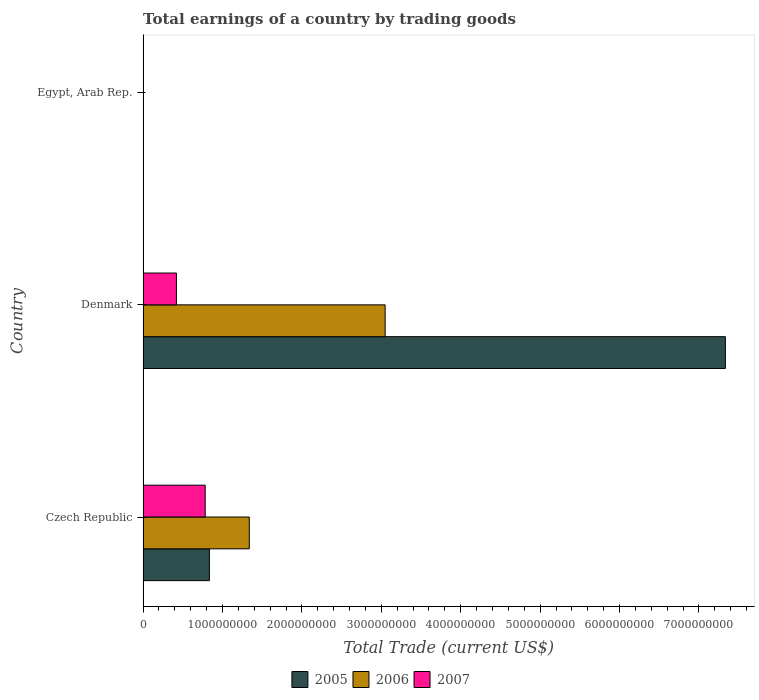How many different coloured bars are there?
Ensure brevity in your answer.  3. Are the number of bars on each tick of the Y-axis equal?
Give a very brief answer. No. How many bars are there on the 3rd tick from the top?
Offer a terse response. 3. How many bars are there on the 3rd tick from the bottom?
Offer a very short reply. 0. In how many cases, is the number of bars for a given country not equal to the number of legend labels?
Offer a terse response. 1. What is the total earnings in 2007 in Czech Republic?
Offer a terse response. 7.83e+08. Across all countries, what is the maximum total earnings in 2005?
Make the answer very short. 7.33e+09. Across all countries, what is the minimum total earnings in 2006?
Provide a short and direct response. 0. In which country was the total earnings in 2006 maximum?
Give a very brief answer. Denmark. What is the total total earnings in 2005 in the graph?
Give a very brief answer. 8.17e+09. What is the difference between the total earnings in 2007 in Czech Republic and that in Denmark?
Keep it short and to the point. 3.62e+08. What is the difference between the total earnings in 2007 in Denmark and the total earnings in 2005 in Czech Republic?
Your answer should be compact. -4.15e+08. What is the average total earnings in 2006 per country?
Keep it short and to the point. 1.46e+09. What is the difference between the total earnings in 2005 and total earnings in 2006 in Czech Republic?
Give a very brief answer. -5.02e+08. In how many countries, is the total earnings in 2006 greater than 3800000000 US$?
Ensure brevity in your answer.  0. What is the ratio of the total earnings in 2005 in Czech Republic to that in Denmark?
Your answer should be very brief. 0.11. Is the total earnings in 2006 in Czech Republic less than that in Denmark?
Provide a short and direct response. Yes. Is the difference between the total earnings in 2005 in Czech Republic and Denmark greater than the difference between the total earnings in 2006 in Czech Republic and Denmark?
Give a very brief answer. No. What is the difference between the highest and the lowest total earnings in 2006?
Offer a very short reply. 3.05e+09. How many bars are there?
Your response must be concise. 6. How many legend labels are there?
Keep it short and to the point. 3. How are the legend labels stacked?
Your response must be concise. Horizontal. What is the title of the graph?
Provide a short and direct response. Total earnings of a country by trading goods. What is the label or title of the X-axis?
Your response must be concise. Total Trade (current US$). What is the Total Trade (current US$) in 2005 in Czech Republic?
Offer a terse response. 8.35e+08. What is the Total Trade (current US$) in 2006 in Czech Republic?
Give a very brief answer. 1.34e+09. What is the Total Trade (current US$) of 2007 in Czech Republic?
Your answer should be very brief. 7.83e+08. What is the Total Trade (current US$) in 2005 in Denmark?
Make the answer very short. 7.33e+09. What is the Total Trade (current US$) of 2006 in Denmark?
Provide a short and direct response. 3.05e+09. What is the Total Trade (current US$) of 2007 in Denmark?
Offer a very short reply. 4.20e+08. What is the Total Trade (current US$) of 2005 in Egypt, Arab Rep.?
Offer a terse response. 0. What is the Total Trade (current US$) of 2006 in Egypt, Arab Rep.?
Provide a succinct answer. 0. Across all countries, what is the maximum Total Trade (current US$) in 2005?
Offer a very short reply. 7.33e+09. Across all countries, what is the maximum Total Trade (current US$) in 2006?
Provide a succinct answer. 3.05e+09. Across all countries, what is the maximum Total Trade (current US$) of 2007?
Your answer should be very brief. 7.83e+08. What is the total Total Trade (current US$) of 2005 in the graph?
Your response must be concise. 8.17e+09. What is the total Total Trade (current US$) of 2006 in the graph?
Offer a very short reply. 4.39e+09. What is the total Total Trade (current US$) in 2007 in the graph?
Offer a very short reply. 1.20e+09. What is the difference between the Total Trade (current US$) of 2005 in Czech Republic and that in Denmark?
Offer a terse response. -6.50e+09. What is the difference between the Total Trade (current US$) of 2006 in Czech Republic and that in Denmark?
Your answer should be very brief. -1.71e+09. What is the difference between the Total Trade (current US$) of 2007 in Czech Republic and that in Denmark?
Your answer should be very brief. 3.62e+08. What is the difference between the Total Trade (current US$) of 2005 in Czech Republic and the Total Trade (current US$) of 2006 in Denmark?
Provide a short and direct response. -2.21e+09. What is the difference between the Total Trade (current US$) of 2005 in Czech Republic and the Total Trade (current US$) of 2007 in Denmark?
Give a very brief answer. 4.15e+08. What is the difference between the Total Trade (current US$) in 2006 in Czech Republic and the Total Trade (current US$) in 2007 in Denmark?
Ensure brevity in your answer.  9.17e+08. What is the average Total Trade (current US$) of 2005 per country?
Provide a succinct answer. 2.72e+09. What is the average Total Trade (current US$) in 2006 per country?
Make the answer very short. 1.46e+09. What is the average Total Trade (current US$) in 2007 per country?
Offer a very short reply. 4.01e+08. What is the difference between the Total Trade (current US$) in 2005 and Total Trade (current US$) in 2006 in Czech Republic?
Ensure brevity in your answer.  -5.02e+08. What is the difference between the Total Trade (current US$) of 2005 and Total Trade (current US$) of 2007 in Czech Republic?
Offer a terse response. 5.27e+07. What is the difference between the Total Trade (current US$) of 2006 and Total Trade (current US$) of 2007 in Czech Republic?
Your response must be concise. 5.55e+08. What is the difference between the Total Trade (current US$) of 2005 and Total Trade (current US$) of 2006 in Denmark?
Your answer should be very brief. 4.28e+09. What is the difference between the Total Trade (current US$) of 2005 and Total Trade (current US$) of 2007 in Denmark?
Provide a succinct answer. 6.91e+09. What is the difference between the Total Trade (current US$) of 2006 and Total Trade (current US$) of 2007 in Denmark?
Your answer should be very brief. 2.63e+09. What is the ratio of the Total Trade (current US$) of 2005 in Czech Republic to that in Denmark?
Give a very brief answer. 0.11. What is the ratio of the Total Trade (current US$) in 2006 in Czech Republic to that in Denmark?
Keep it short and to the point. 0.44. What is the ratio of the Total Trade (current US$) in 2007 in Czech Republic to that in Denmark?
Your answer should be compact. 1.86. What is the difference between the highest and the lowest Total Trade (current US$) of 2005?
Your answer should be compact. 7.33e+09. What is the difference between the highest and the lowest Total Trade (current US$) of 2006?
Offer a very short reply. 3.05e+09. What is the difference between the highest and the lowest Total Trade (current US$) in 2007?
Your answer should be very brief. 7.83e+08. 